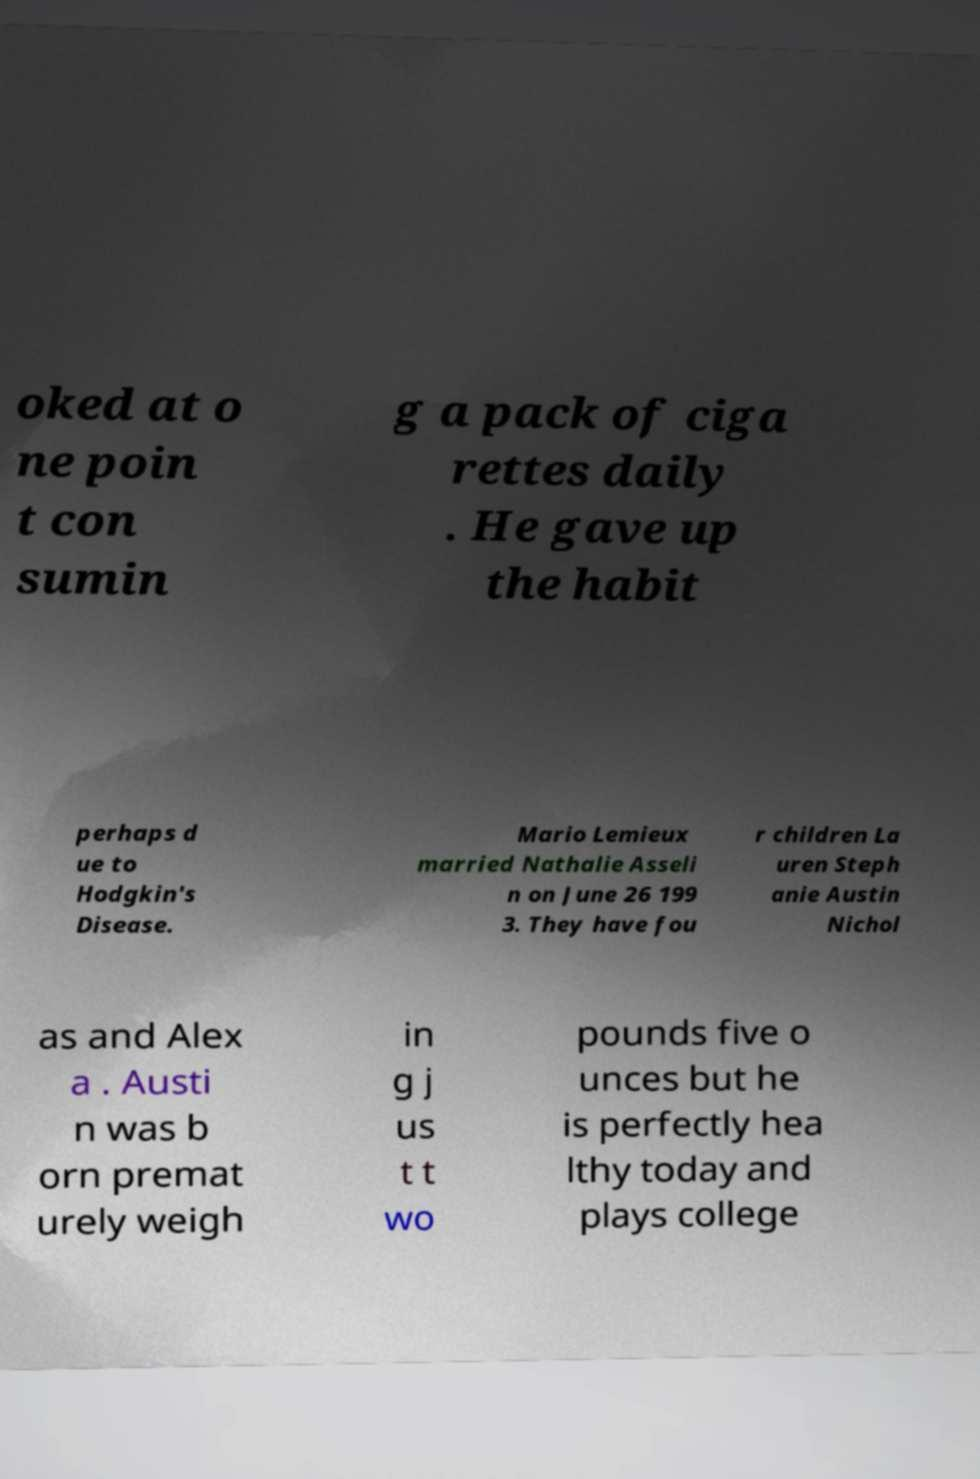Could you assist in decoding the text presented in this image and type it out clearly? oked at o ne poin t con sumin g a pack of ciga rettes daily . He gave up the habit perhaps d ue to Hodgkin's Disease. Mario Lemieux married Nathalie Asseli n on June 26 199 3. They have fou r children La uren Steph anie Austin Nichol as and Alex a . Austi n was b orn premat urely weigh in g j us t t wo pounds five o unces but he is perfectly hea lthy today and plays college 